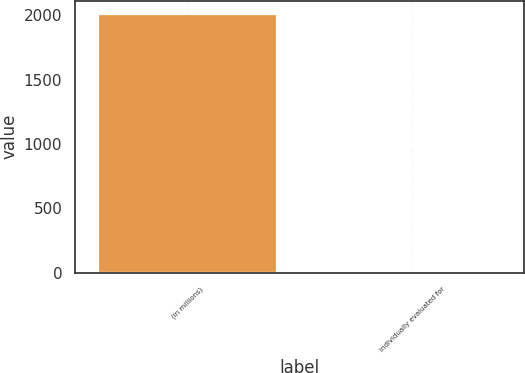<chart> <loc_0><loc_0><loc_500><loc_500><bar_chart><fcel>(In millions)<fcel>Individually evaluated for<nl><fcel>2012<fcel>11<nl></chart> 